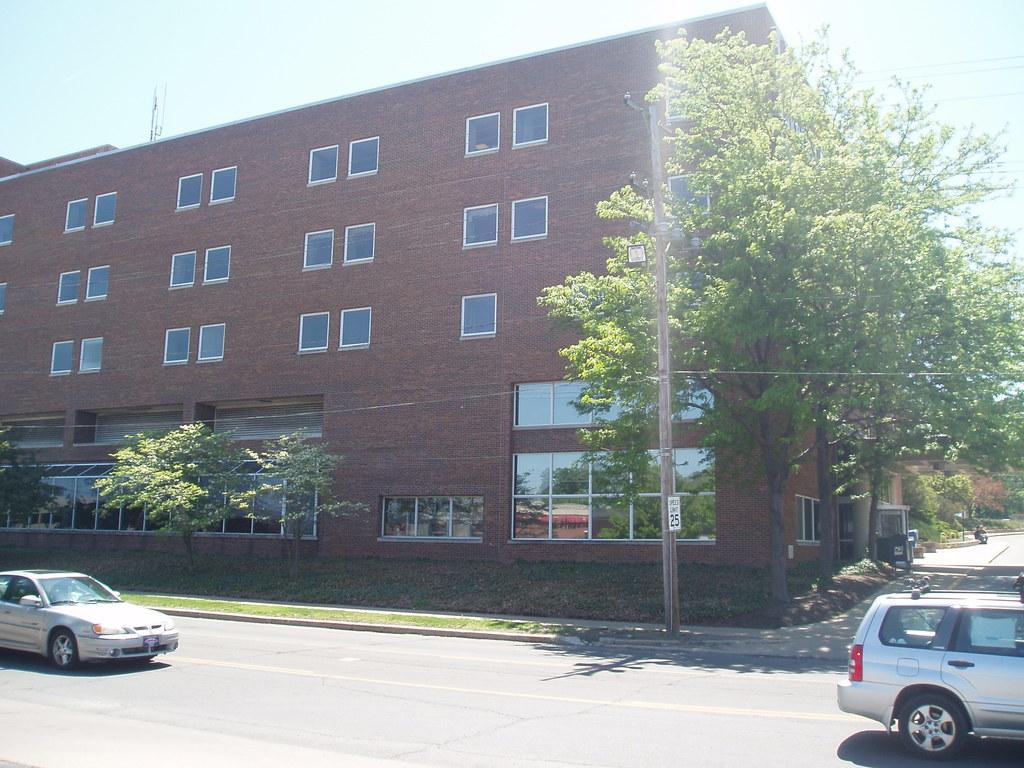What type of structure is visible in the image? There is a building in the image. What can be seen in front of the building? There are trees in front of the building. What mode of transportation can be seen on the road in the image? There are cars on the road in the image. What language are the cows speaking in the image? There are no cows present in the image, so it is not possible to determine what language they might be speaking. 